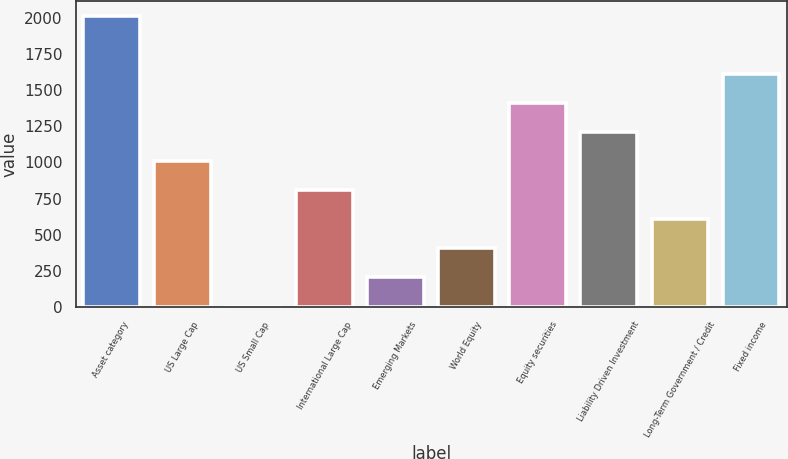<chart> <loc_0><loc_0><loc_500><loc_500><bar_chart><fcel>Asset category<fcel>US Large Cap<fcel>US Small Cap<fcel>International Large Cap<fcel>Emerging Markets<fcel>World Equity<fcel>Equity securities<fcel>Liability Driven Investment<fcel>Long-Term Government / Credit<fcel>Fixed income<nl><fcel>2014<fcel>1009<fcel>4<fcel>808<fcel>205<fcel>406<fcel>1411<fcel>1210<fcel>607<fcel>1612<nl></chart> 